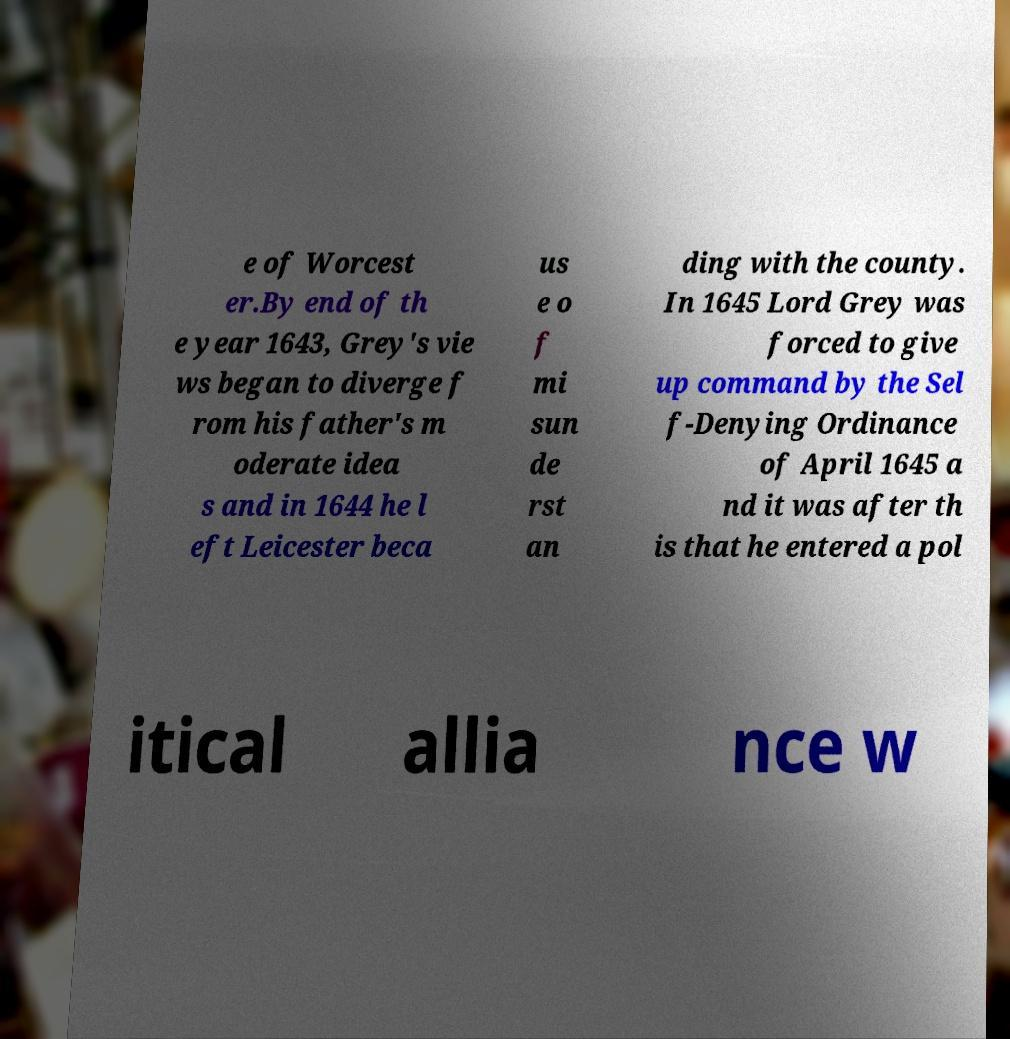What messages or text are displayed in this image? I need them in a readable, typed format. e of Worcest er.By end of th e year 1643, Grey's vie ws began to diverge f rom his father's m oderate idea s and in 1644 he l eft Leicester beca us e o f mi sun de rst an ding with the county. In 1645 Lord Grey was forced to give up command by the Sel f-Denying Ordinance of April 1645 a nd it was after th is that he entered a pol itical allia nce w 